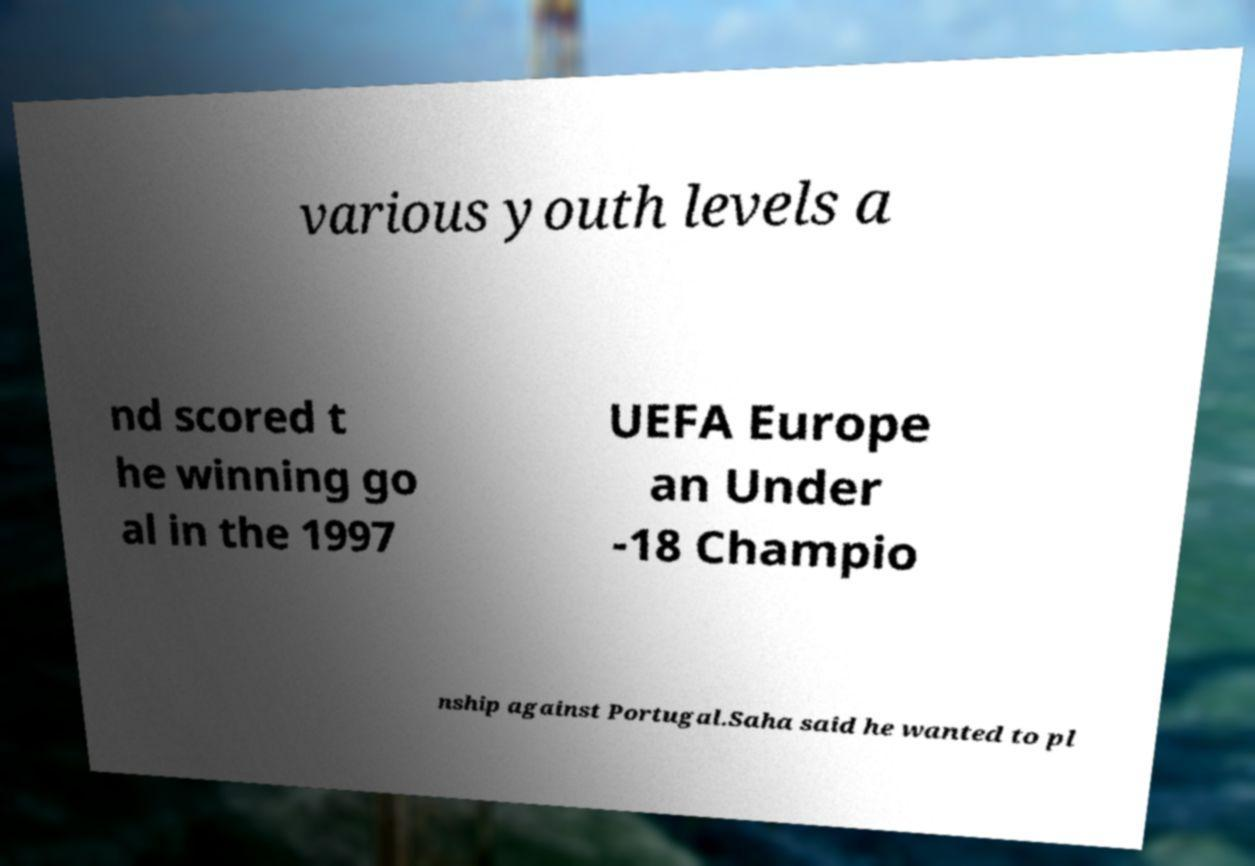Can you read and provide the text displayed in the image?This photo seems to have some interesting text. Can you extract and type it out for me? various youth levels a nd scored t he winning go al in the 1997 UEFA Europe an Under -18 Champio nship against Portugal.Saha said he wanted to pl 